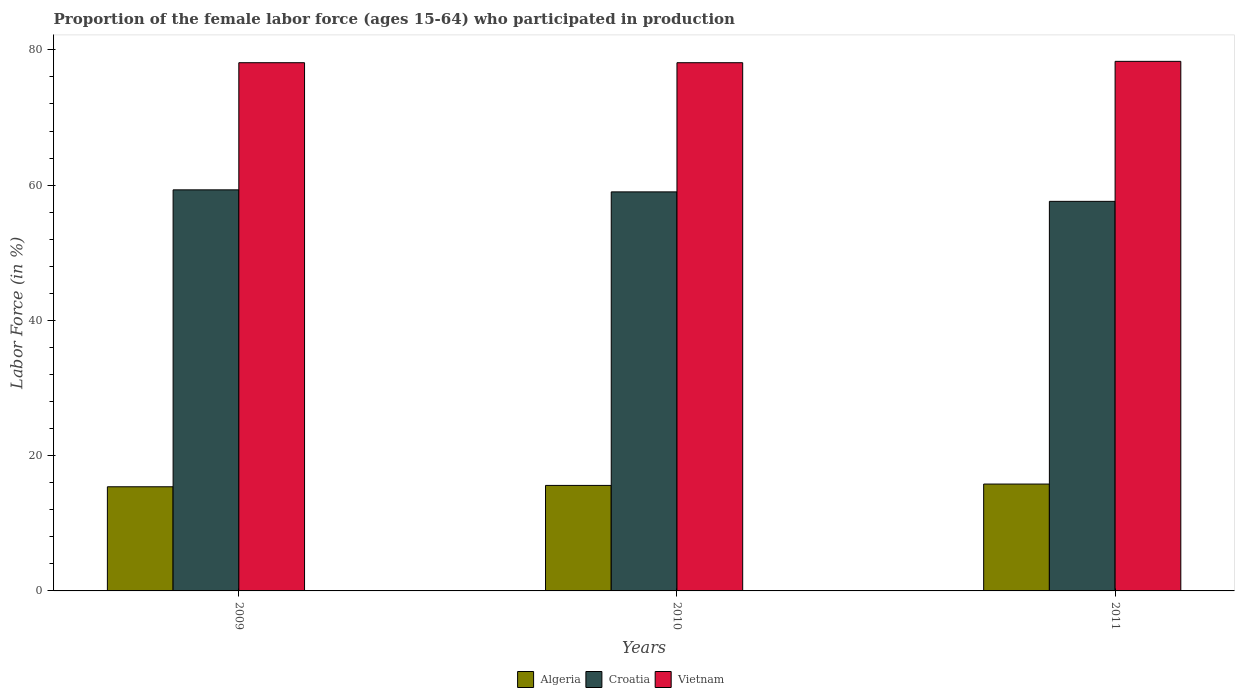How many groups of bars are there?
Provide a short and direct response. 3. Are the number of bars on each tick of the X-axis equal?
Provide a short and direct response. Yes. How many bars are there on the 2nd tick from the right?
Offer a very short reply. 3. What is the label of the 1st group of bars from the left?
Provide a short and direct response. 2009. What is the proportion of the female labor force who participated in production in Croatia in 2011?
Keep it short and to the point. 57.6. Across all years, what is the maximum proportion of the female labor force who participated in production in Vietnam?
Ensure brevity in your answer.  78.3. Across all years, what is the minimum proportion of the female labor force who participated in production in Croatia?
Provide a succinct answer. 57.6. In which year was the proportion of the female labor force who participated in production in Vietnam maximum?
Provide a short and direct response. 2011. In which year was the proportion of the female labor force who participated in production in Croatia minimum?
Keep it short and to the point. 2011. What is the total proportion of the female labor force who participated in production in Vietnam in the graph?
Ensure brevity in your answer.  234.5. What is the difference between the proportion of the female labor force who participated in production in Vietnam in 2010 and that in 2011?
Provide a succinct answer. -0.2. What is the difference between the proportion of the female labor force who participated in production in Vietnam in 2011 and the proportion of the female labor force who participated in production in Algeria in 2009?
Offer a terse response. 62.9. What is the average proportion of the female labor force who participated in production in Algeria per year?
Give a very brief answer. 15.6. In the year 2011, what is the difference between the proportion of the female labor force who participated in production in Algeria and proportion of the female labor force who participated in production in Croatia?
Your answer should be very brief. -41.8. In how many years, is the proportion of the female labor force who participated in production in Croatia greater than 8 %?
Keep it short and to the point. 3. What is the ratio of the proportion of the female labor force who participated in production in Croatia in 2009 to that in 2010?
Give a very brief answer. 1.01. Is the proportion of the female labor force who participated in production in Algeria in 2009 less than that in 2010?
Give a very brief answer. Yes. What is the difference between the highest and the second highest proportion of the female labor force who participated in production in Algeria?
Offer a terse response. 0.2. What is the difference between the highest and the lowest proportion of the female labor force who participated in production in Vietnam?
Give a very brief answer. 0.2. Is the sum of the proportion of the female labor force who participated in production in Croatia in 2009 and 2011 greater than the maximum proportion of the female labor force who participated in production in Algeria across all years?
Provide a short and direct response. Yes. What does the 2nd bar from the left in 2009 represents?
Your answer should be very brief. Croatia. What does the 2nd bar from the right in 2011 represents?
Your answer should be compact. Croatia. Are all the bars in the graph horizontal?
Provide a succinct answer. No. How many years are there in the graph?
Provide a short and direct response. 3. Are the values on the major ticks of Y-axis written in scientific E-notation?
Ensure brevity in your answer.  No. Does the graph contain grids?
Give a very brief answer. No. What is the title of the graph?
Your answer should be compact. Proportion of the female labor force (ages 15-64) who participated in production. Does "Middle East & North Africa (all income levels)" appear as one of the legend labels in the graph?
Provide a succinct answer. No. What is the label or title of the X-axis?
Offer a very short reply. Years. What is the label or title of the Y-axis?
Offer a terse response. Labor Force (in %). What is the Labor Force (in %) in Algeria in 2009?
Provide a short and direct response. 15.4. What is the Labor Force (in %) of Croatia in 2009?
Give a very brief answer. 59.3. What is the Labor Force (in %) of Vietnam in 2009?
Give a very brief answer. 78.1. What is the Labor Force (in %) of Algeria in 2010?
Your answer should be compact. 15.6. What is the Labor Force (in %) of Vietnam in 2010?
Ensure brevity in your answer.  78.1. What is the Labor Force (in %) in Algeria in 2011?
Offer a terse response. 15.8. What is the Labor Force (in %) in Croatia in 2011?
Keep it short and to the point. 57.6. What is the Labor Force (in %) of Vietnam in 2011?
Your response must be concise. 78.3. Across all years, what is the maximum Labor Force (in %) of Algeria?
Give a very brief answer. 15.8. Across all years, what is the maximum Labor Force (in %) of Croatia?
Offer a very short reply. 59.3. Across all years, what is the maximum Labor Force (in %) in Vietnam?
Offer a terse response. 78.3. Across all years, what is the minimum Labor Force (in %) of Algeria?
Offer a very short reply. 15.4. Across all years, what is the minimum Labor Force (in %) of Croatia?
Keep it short and to the point. 57.6. Across all years, what is the minimum Labor Force (in %) of Vietnam?
Your answer should be very brief. 78.1. What is the total Labor Force (in %) of Algeria in the graph?
Make the answer very short. 46.8. What is the total Labor Force (in %) in Croatia in the graph?
Ensure brevity in your answer.  175.9. What is the total Labor Force (in %) in Vietnam in the graph?
Your answer should be compact. 234.5. What is the difference between the Labor Force (in %) in Algeria in 2009 and that in 2010?
Offer a terse response. -0.2. What is the difference between the Labor Force (in %) in Croatia in 2009 and that in 2010?
Your response must be concise. 0.3. What is the difference between the Labor Force (in %) in Vietnam in 2009 and that in 2010?
Ensure brevity in your answer.  0. What is the difference between the Labor Force (in %) in Croatia in 2009 and that in 2011?
Your response must be concise. 1.7. What is the difference between the Labor Force (in %) of Vietnam in 2009 and that in 2011?
Keep it short and to the point. -0.2. What is the difference between the Labor Force (in %) of Algeria in 2010 and that in 2011?
Ensure brevity in your answer.  -0.2. What is the difference between the Labor Force (in %) in Croatia in 2010 and that in 2011?
Make the answer very short. 1.4. What is the difference between the Labor Force (in %) of Algeria in 2009 and the Labor Force (in %) of Croatia in 2010?
Offer a terse response. -43.6. What is the difference between the Labor Force (in %) of Algeria in 2009 and the Labor Force (in %) of Vietnam in 2010?
Provide a short and direct response. -62.7. What is the difference between the Labor Force (in %) in Croatia in 2009 and the Labor Force (in %) in Vietnam in 2010?
Give a very brief answer. -18.8. What is the difference between the Labor Force (in %) in Algeria in 2009 and the Labor Force (in %) in Croatia in 2011?
Your answer should be compact. -42.2. What is the difference between the Labor Force (in %) of Algeria in 2009 and the Labor Force (in %) of Vietnam in 2011?
Offer a very short reply. -62.9. What is the difference between the Labor Force (in %) in Algeria in 2010 and the Labor Force (in %) in Croatia in 2011?
Your response must be concise. -42. What is the difference between the Labor Force (in %) in Algeria in 2010 and the Labor Force (in %) in Vietnam in 2011?
Give a very brief answer. -62.7. What is the difference between the Labor Force (in %) in Croatia in 2010 and the Labor Force (in %) in Vietnam in 2011?
Your response must be concise. -19.3. What is the average Labor Force (in %) of Croatia per year?
Your response must be concise. 58.63. What is the average Labor Force (in %) in Vietnam per year?
Your answer should be compact. 78.17. In the year 2009, what is the difference between the Labor Force (in %) in Algeria and Labor Force (in %) in Croatia?
Make the answer very short. -43.9. In the year 2009, what is the difference between the Labor Force (in %) in Algeria and Labor Force (in %) in Vietnam?
Your answer should be compact. -62.7. In the year 2009, what is the difference between the Labor Force (in %) in Croatia and Labor Force (in %) in Vietnam?
Keep it short and to the point. -18.8. In the year 2010, what is the difference between the Labor Force (in %) in Algeria and Labor Force (in %) in Croatia?
Your answer should be compact. -43.4. In the year 2010, what is the difference between the Labor Force (in %) of Algeria and Labor Force (in %) of Vietnam?
Provide a short and direct response. -62.5. In the year 2010, what is the difference between the Labor Force (in %) in Croatia and Labor Force (in %) in Vietnam?
Ensure brevity in your answer.  -19.1. In the year 2011, what is the difference between the Labor Force (in %) of Algeria and Labor Force (in %) of Croatia?
Keep it short and to the point. -41.8. In the year 2011, what is the difference between the Labor Force (in %) of Algeria and Labor Force (in %) of Vietnam?
Ensure brevity in your answer.  -62.5. In the year 2011, what is the difference between the Labor Force (in %) in Croatia and Labor Force (in %) in Vietnam?
Your answer should be compact. -20.7. What is the ratio of the Labor Force (in %) of Algeria in 2009 to that in 2010?
Make the answer very short. 0.99. What is the ratio of the Labor Force (in %) of Croatia in 2009 to that in 2010?
Your answer should be very brief. 1.01. What is the ratio of the Labor Force (in %) in Vietnam in 2009 to that in 2010?
Your answer should be compact. 1. What is the ratio of the Labor Force (in %) of Algeria in 2009 to that in 2011?
Offer a very short reply. 0.97. What is the ratio of the Labor Force (in %) in Croatia in 2009 to that in 2011?
Offer a terse response. 1.03. What is the ratio of the Labor Force (in %) of Vietnam in 2009 to that in 2011?
Provide a succinct answer. 1. What is the ratio of the Labor Force (in %) in Algeria in 2010 to that in 2011?
Ensure brevity in your answer.  0.99. What is the ratio of the Labor Force (in %) in Croatia in 2010 to that in 2011?
Your answer should be very brief. 1.02. What is the ratio of the Labor Force (in %) of Vietnam in 2010 to that in 2011?
Your answer should be compact. 1. What is the difference between the highest and the second highest Labor Force (in %) in Algeria?
Offer a terse response. 0.2. What is the difference between the highest and the second highest Labor Force (in %) of Vietnam?
Provide a succinct answer. 0.2. What is the difference between the highest and the lowest Labor Force (in %) in Vietnam?
Offer a terse response. 0.2. 